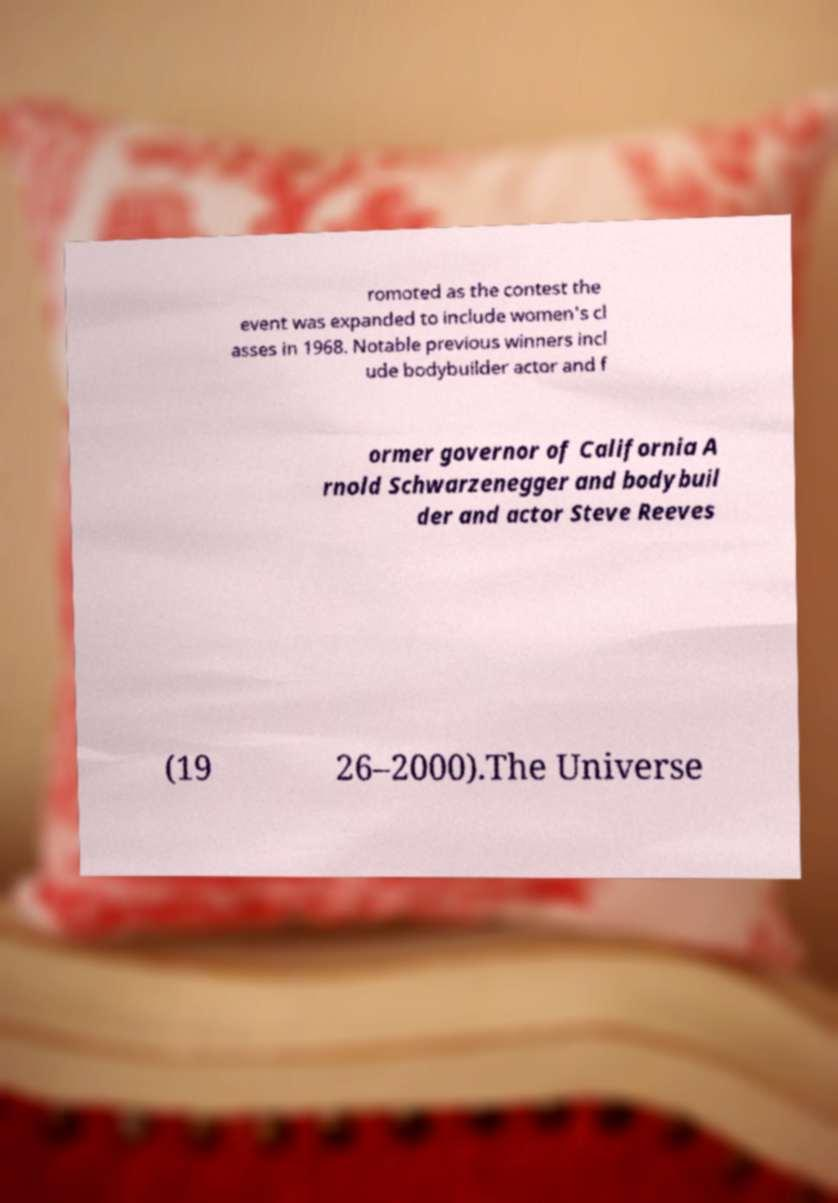Could you extract and type out the text from this image? romoted as the contest the event was expanded to include women's cl asses in 1968. Notable previous winners incl ude bodybuilder actor and f ormer governor of California A rnold Schwarzenegger and bodybuil der and actor Steve Reeves (19 26–2000).The Universe 